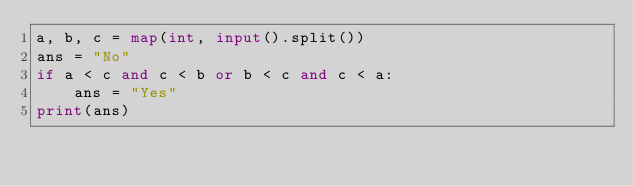Convert code to text. <code><loc_0><loc_0><loc_500><loc_500><_Python_>a, b, c = map(int, input().split())
ans = "No"
if a < c and c < b or b < c and c < a:
    ans = "Yes"
print(ans)
</code> 